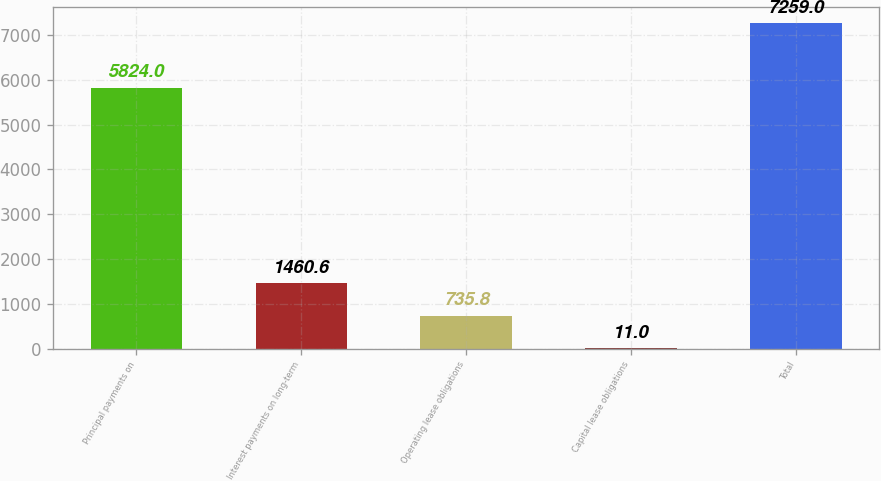Convert chart. <chart><loc_0><loc_0><loc_500><loc_500><bar_chart><fcel>Principal payments on<fcel>Interest payments on long-term<fcel>Operating lease obligations<fcel>Capital lease obligations<fcel>Total<nl><fcel>5824<fcel>1460.6<fcel>735.8<fcel>11<fcel>7259<nl></chart> 